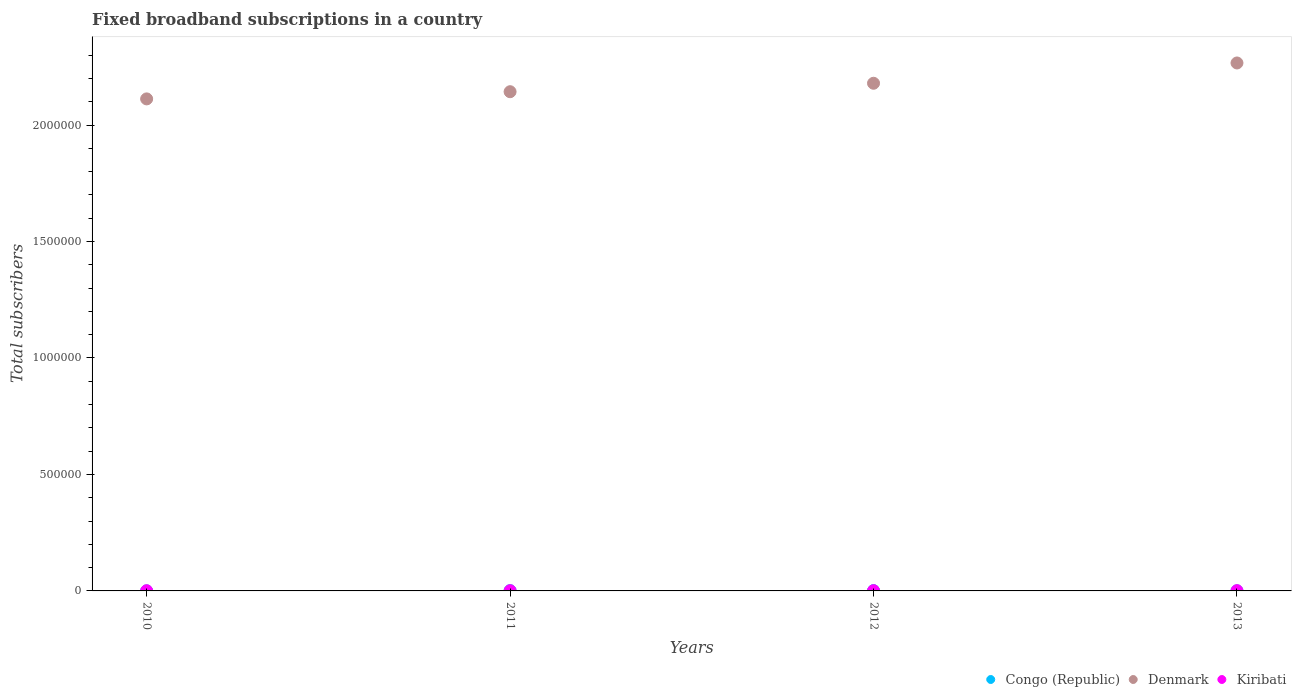How many different coloured dotlines are there?
Provide a short and direct response. 3. What is the number of broadband subscriptions in Congo (Republic) in 2013?
Offer a very short reply. 438. Across all years, what is the maximum number of broadband subscriptions in Congo (Republic)?
Ensure brevity in your answer.  1392. Across all years, what is the minimum number of broadband subscriptions in Kiribati?
Offer a terse response. 846. In which year was the number of broadband subscriptions in Congo (Republic) minimum?
Offer a terse response. 2010. What is the total number of broadband subscriptions in Denmark in the graph?
Your response must be concise. 8.70e+06. What is the difference between the number of broadband subscriptions in Kiribati in 2011 and that in 2013?
Your answer should be compact. -180. What is the difference between the number of broadband subscriptions in Kiribati in 2013 and the number of broadband subscriptions in Denmark in 2012?
Give a very brief answer. -2.18e+06. What is the average number of broadband subscriptions in Denmark per year?
Provide a short and direct response. 2.18e+06. In the year 2012, what is the difference between the number of broadband subscriptions in Congo (Republic) and number of broadband subscriptions in Denmark?
Your answer should be very brief. -2.18e+06. In how many years, is the number of broadband subscriptions in Congo (Republic) greater than 300000?
Offer a very short reply. 0. What is the ratio of the number of broadband subscriptions in Denmark in 2010 to that in 2012?
Give a very brief answer. 0.97. Is the number of broadband subscriptions in Congo (Republic) in 2011 less than that in 2013?
Keep it short and to the point. No. What is the difference between the highest and the second highest number of broadband subscriptions in Congo (Republic)?
Offer a terse response. 81. What is the difference between the highest and the lowest number of broadband subscriptions in Congo (Republic)?
Provide a short and direct response. 1142. In how many years, is the number of broadband subscriptions in Kiribati greater than the average number of broadband subscriptions in Kiribati taken over all years?
Offer a very short reply. 2. Is the number of broadband subscriptions in Congo (Republic) strictly greater than the number of broadband subscriptions in Denmark over the years?
Provide a succinct answer. No. Is the number of broadband subscriptions in Congo (Republic) strictly less than the number of broadband subscriptions in Denmark over the years?
Keep it short and to the point. Yes. How many dotlines are there?
Provide a succinct answer. 3. Are the values on the major ticks of Y-axis written in scientific E-notation?
Your answer should be compact. No. Does the graph contain grids?
Your answer should be compact. No. How many legend labels are there?
Make the answer very short. 3. What is the title of the graph?
Your response must be concise. Fixed broadband subscriptions in a country. Does "Kosovo" appear as one of the legend labels in the graph?
Offer a very short reply. No. What is the label or title of the X-axis?
Your answer should be very brief. Years. What is the label or title of the Y-axis?
Provide a succinct answer. Total subscribers. What is the Total subscribers in Congo (Republic) in 2010?
Offer a terse response. 250. What is the Total subscribers of Denmark in 2010?
Give a very brief answer. 2.11e+06. What is the Total subscribers in Kiribati in 2010?
Your answer should be very brief. 846. What is the Total subscribers in Congo (Republic) in 2011?
Provide a short and direct response. 1311. What is the Total subscribers in Denmark in 2011?
Ensure brevity in your answer.  2.14e+06. What is the Total subscribers in Kiribati in 2011?
Offer a terse response. 920. What is the Total subscribers in Congo (Republic) in 2012?
Keep it short and to the point. 1392. What is the Total subscribers of Denmark in 2012?
Give a very brief answer. 2.18e+06. What is the Total subscribers of Kiribati in 2012?
Your answer should be compact. 1000. What is the Total subscribers in Congo (Republic) in 2013?
Ensure brevity in your answer.  438. What is the Total subscribers in Denmark in 2013?
Offer a very short reply. 2.27e+06. What is the Total subscribers in Kiribati in 2013?
Keep it short and to the point. 1100. Across all years, what is the maximum Total subscribers of Congo (Republic)?
Offer a very short reply. 1392. Across all years, what is the maximum Total subscribers in Denmark?
Give a very brief answer. 2.27e+06. Across all years, what is the maximum Total subscribers of Kiribati?
Your response must be concise. 1100. Across all years, what is the minimum Total subscribers of Congo (Republic)?
Offer a very short reply. 250. Across all years, what is the minimum Total subscribers in Denmark?
Offer a very short reply. 2.11e+06. Across all years, what is the minimum Total subscribers of Kiribati?
Provide a succinct answer. 846. What is the total Total subscribers in Congo (Republic) in the graph?
Your response must be concise. 3391. What is the total Total subscribers in Denmark in the graph?
Offer a very short reply. 8.70e+06. What is the total Total subscribers of Kiribati in the graph?
Provide a short and direct response. 3866. What is the difference between the Total subscribers of Congo (Republic) in 2010 and that in 2011?
Make the answer very short. -1061. What is the difference between the Total subscribers of Denmark in 2010 and that in 2011?
Ensure brevity in your answer.  -3.08e+04. What is the difference between the Total subscribers of Kiribati in 2010 and that in 2011?
Offer a very short reply. -74. What is the difference between the Total subscribers in Congo (Republic) in 2010 and that in 2012?
Offer a very short reply. -1142. What is the difference between the Total subscribers of Denmark in 2010 and that in 2012?
Give a very brief answer. -6.71e+04. What is the difference between the Total subscribers in Kiribati in 2010 and that in 2012?
Ensure brevity in your answer.  -154. What is the difference between the Total subscribers in Congo (Republic) in 2010 and that in 2013?
Your response must be concise. -188. What is the difference between the Total subscribers of Denmark in 2010 and that in 2013?
Make the answer very short. -1.54e+05. What is the difference between the Total subscribers of Kiribati in 2010 and that in 2013?
Keep it short and to the point. -254. What is the difference between the Total subscribers in Congo (Republic) in 2011 and that in 2012?
Provide a short and direct response. -81. What is the difference between the Total subscribers of Denmark in 2011 and that in 2012?
Keep it short and to the point. -3.63e+04. What is the difference between the Total subscribers of Kiribati in 2011 and that in 2012?
Make the answer very short. -80. What is the difference between the Total subscribers of Congo (Republic) in 2011 and that in 2013?
Give a very brief answer. 873. What is the difference between the Total subscribers of Denmark in 2011 and that in 2013?
Your answer should be very brief. -1.23e+05. What is the difference between the Total subscribers in Kiribati in 2011 and that in 2013?
Offer a very short reply. -180. What is the difference between the Total subscribers in Congo (Republic) in 2012 and that in 2013?
Make the answer very short. 954. What is the difference between the Total subscribers of Denmark in 2012 and that in 2013?
Your answer should be very brief. -8.71e+04. What is the difference between the Total subscribers of Kiribati in 2012 and that in 2013?
Your answer should be compact. -100. What is the difference between the Total subscribers of Congo (Republic) in 2010 and the Total subscribers of Denmark in 2011?
Your answer should be very brief. -2.14e+06. What is the difference between the Total subscribers in Congo (Republic) in 2010 and the Total subscribers in Kiribati in 2011?
Your answer should be very brief. -670. What is the difference between the Total subscribers in Denmark in 2010 and the Total subscribers in Kiribati in 2011?
Provide a short and direct response. 2.11e+06. What is the difference between the Total subscribers in Congo (Republic) in 2010 and the Total subscribers in Denmark in 2012?
Provide a short and direct response. -2.18e+06. What is the difference between the Total subscribers of Congo (Republic) in 2010 and the Total subscribers of Kiribati in 2012?
Provide a short and direct response. -750. What is the difference between the Total subscribers in Denmark in 2010 and the Total subscribers in Kiribati in 2012?
Your answer should be compact. 2.11e+06. What is the difference between the Total subscribers of Congo (Republic) in 2010 and the Total subscribers of Denmark in 2013?
Offer a terse response. -2.27e+06. What is the difference between the Total subscribers in Congo (Republic) in 2010 and the Total subscribers in Kiribati in 2013?
Ensure brevity in your answer.  -850. What is the difference between the Total subscribers in Denmark in 2010 and the Total subscribers in Kiribati in 2013?
Ensure brevity in your answer.  2.11e+06. What is the difference between the Total subscribers in Congo (Republic) in 2011 and the Total subscribers in Denmark in 2012?
Keep it short and to the point. -2.18e+06. What is the difference between the Total subscribers of Congo (Republic) in 2011 and the Total subscribers of Kiribati in 2012?
Keep it short and to the point. 311. What is the difference between the Total subscribers in Denmark in 2011 and the Total subscribers in Kiribati in 2012?
Offer a terse response. 2.14e+06. What is the difference between the Total subscribers in Congo (Republic) in 2011 and the Total subscribers in Denmark in 2013?
Offer a terse response. -2.27e+06. What is the difference between the Total subscribers in Congo (Republic) in 2011 and the Total subscribers in Kiribati in 2013?
Ensure brevity in your answer.  211. What is the difference between the Total subscribers in Denmark in 2011 and the Total subscribers in Kiribati in 2013?
Your answer should be very brief. 2.14e+06. What is the difference between the Total subscribers of Congo (Republic) in 2012 and the Total subscribers of Denmark in 2013?
Your response must be concise. -2.27e+06. What is the difference between the Total subscribers in Congo (Republic) in 2012 and the Total subscribers in Kiribati in 2013?
Make the answer very short. 292. What is the difference between the Total subscribers in Denmark in 2012 and the Total subscribers in Kiribati in 2013?
Make the answer very short. 2.18e+06. What is the average Total subscribers in Congo (Republic) per year?
Provide a succinct answer. 847.75. What is the average Total subscribers of Denmark per year?
Give a very brief answer. 2.18e+06. What is the average Total subscribers in Kiribati per year?
Provide a short and direct response. 966.5. In the year 2010, what is the difference between the Total subscribers of Congo (Republic) and Total subscribers of Denmark?
Offer a very short reply. -2.11e+06. In the year 2010, what is the difference between the Total subscribers in Congo (Republic) and Total subscribers in Kiribati?
Offer a terse response. -596. In the year 2010, what is the difference between the Total subscribers in Denmark and Total subscribers in Kiribati?
Offer a terse response. 2.11e+06. In the year 2011, what is the difference between the Total subscribers in Congo (Republic) and Total subscribers in Denmark?
Your answer should be very brief. -2.14e+06. In the year 2011, what is the difference between the Total subscribers of Congo (Republic) and Total subscribers of Kiribati?
Ensure brevity in your answer.  391. In the year 2011, what is the difference between the Total subscribers of Denmark and Total subscribers of Kiribati?
Ensure brevity in your answer.  2.14e+06. In the year 2012, what is the difference between the Total subscribers of Congo (Republic) and Total subscribers of Denmark?
Keep it short and to the point. -2.18e+06. In the year 2012, what is the difference between the Total subscribers of Congo (Republic) and Total subscribers of Kiribati?
Your answer should be very brief. 392. In the year 2012, what is the difference between the Total subscribers in Denmark and Total subscribers in Kiribati?
Keep it short and to the point. 2.18e+06. In the year 2013, what is the difference between the Total subscribers in Congo (Republic) and Total subscribers in Denmark?
Your response must be concise. -2.27e+06. In the year 2013, what is the difference between the Total subscribers in Congo (Republic) and Total subscribers in Kiribati?
Offer a terse response. -662. In the year 2013, what is the difference between the Total subscribers of Denmark and Total subscribers of Kiribati?
Offer a terse response. 2.27e+06. What is the ratio of the Total subscribers of Congo (Republic) in 2010 to that in 2011?
Ensure brevity in your answer.  0.19. What is the ratio of the Total subscribers of Denmark in 2010 to that in 2011?
Offer a very short reply. 0.99. What is the ratio of the Total subscribers in Kiribati in 2010 to that in 2011?
Keep it short and to the point. 0.92. What is the ratio of the Total subscribers of Congo (Republic) in 2010 to that in 2012?
Make the answer very short. 0.18. What is the ratio of the Total subscribers in Denmark in 2010 to that in 2012?
Give a very brief answer. 0.97. What is the ratio of the Total subscribers of Kiribati in 2010 to that in 2012?
Ensure brevity in your answer.  0.85. What is the ratio of the Total subscribers of Congo (Republic) in 2010 to that in 2013?
Ensure brevity in your answer.  0.57. What is the ratio of the Total subscribers in Denmark in 2010 to that in 2013?
Your answer should be very brief. 0.93. What is the ratio of the Total subscribers of Kiribati in 2010 to that in 2013?
Your answer should be compact. 0.77. What is the ratio of the Total subscribers of Congo (Republic) in 2011 to that in 2012?
Offer a terse response. 0.94. What is the ratio of the Total subscribers in Denmark in 2011 to that in 2012?
Your response must be concise. 0.98. What is the ratio of the Total subscribers of Kiribati in 2011 to that in 2012?
Provide a short and direct response. 0.92. What is the ratio of the Total subscribers in Congo (Republic) in 2011 to that in 2013?
Provide a succinct answer. 2.99. What is the ratio of the Total subscribers in Denmark in 2011 to that in 2013?
Give a very brief answer. 0.95. What is the ratio of the Total subscribers of Kiribati in 2011 to that in 2013?
Ensure brevity in your answer.  0.84. What is the ratio of the Total subscribers in Congo (Republic) in 2012 to that in 2013?
Provide a succinct answer. 3.18. What is the ratio of the Total subscribers of Denmark in 2012 to that in 2013?
Keep it short and to the point. 0.96. What is the ratio of the Total subscribers of Kiribati in 2012 to that in 2013?
Offer a very short reply. 0.91. What is the difference between the highest and the second highest Total subscribers of Denmark?
Your answer should be very brief. 8.71e+04. What is the difference between the highest and the lowest Total subscribers of Congo (Republic)?
Your response must be concise. 1142. What is the difference between the highest and the lowest Total subscribers of Denmark?
Give a very brief answer. 1.54e+05. What is the difference between the highest and the lowest Total subscribers of Kiribati?
Offer a terse response. 254. 